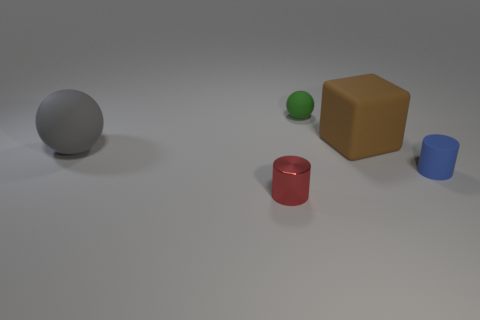It looks like various solid geometrical objects are staged here. Could you propose a simple mathematical problem involving the volumes of these shapes? Certainly! Assuming the sphere has a radius of 'r', the cube has an edge length of 'a', and the cylinder has a height 'h' and radius 'r', a problem could involve calculating the sum of their volumes. The volume of a sphere is (4/3)πr^3, the volume of a cube is a^3, and the volume of a cylinder is πr^2h. You could find their total volumes with the dimensions provided. 